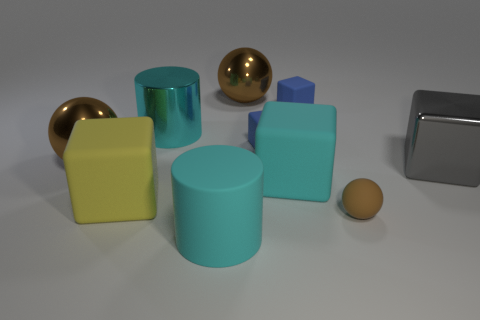Subtract all cyan cubes. How many cubes are left? 4 Subtract all big cyan blocks. How many blocks are left? 4 Subtract all red cubes. Subtract all cyan balls. How many cubes are left? 5 Subtract all balls. How many objects are left? 7 Add 5 big yellow things. How many big yellow things are left? 6 Add 9 gray cubes. How many gray cubes exist? 10 Subtract 0 yellow cylinders. How many objects are left? 10 Subtract all big gray matte spheres. Subtract all gray things. How many objects are left? 9 